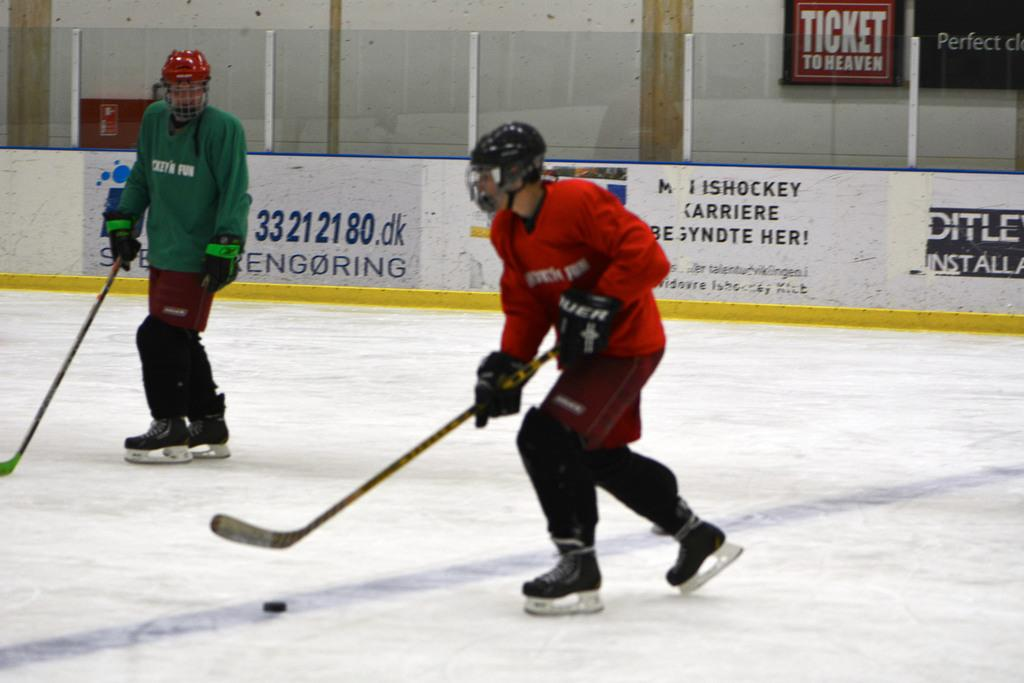<image>
Provide a brief description of the given image. Ticket to heaven is advertised at the ice hockey rink. 